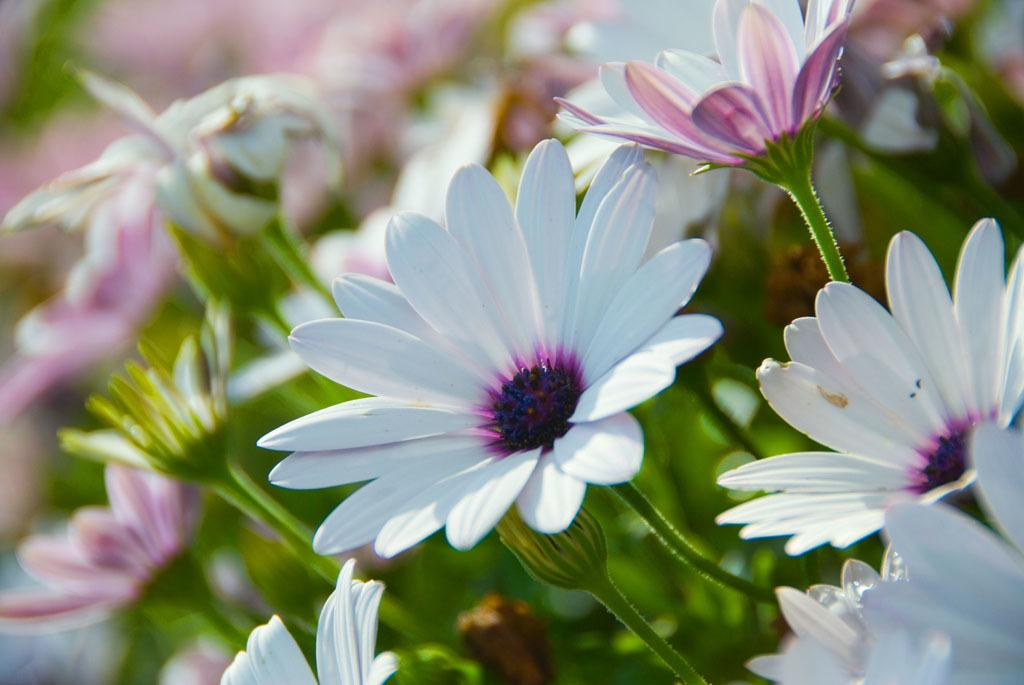What is the main subject of the image? The main subject of the image is flowers. What color are the flowers in the image? The flowers in the image are white in color. Can you see a deer interacting with the flowers in the image? There is no deer present in the image; it only features white flowers. What type of spark can be seen coming from the flowers in the image? There is no spark present in the image; it only features white flowers. 